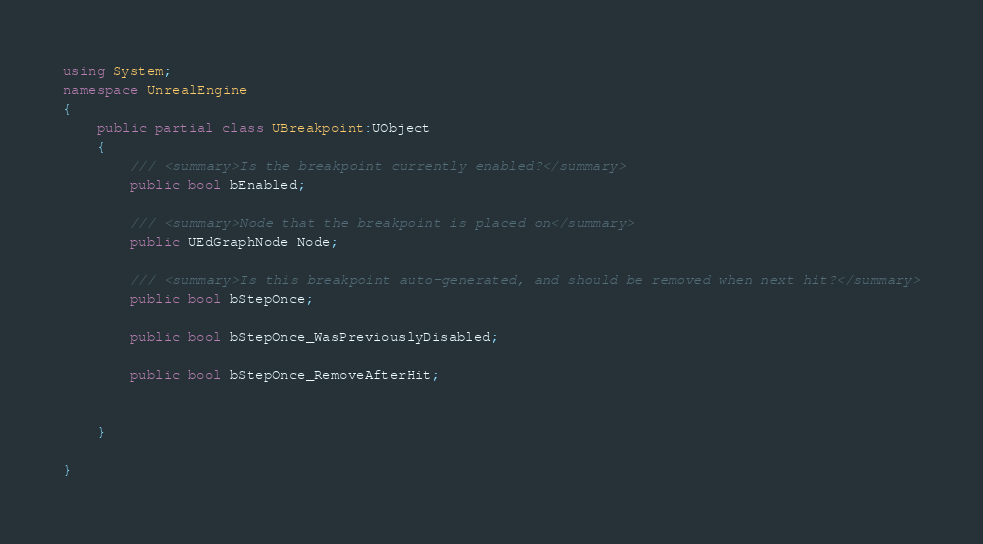<code> <loc_0><loc_0><loc_500><loc_500><_C#_>using System;
namespace UnrealEngine
{
	public partial class UBreakpoint:UObject
	{
		/// <summary>Is the breakpoint currently enabled?</summary>
		public bool bEnabled;
		
		/// <summary>Node that the breakpoint is placed on</summary>
		public UEdGraphNode Node;
		
		/// <summary>Is this breakpoint auto-generated, and should be removed when next hit?</summary>
		public bool bStepOnce;
		
		public bool bStepOnce_WasPreviouslyDisabled;
		
		public bool bStepOnce_RemoveAfterHit;
		
		
	}
	
}
</code> 